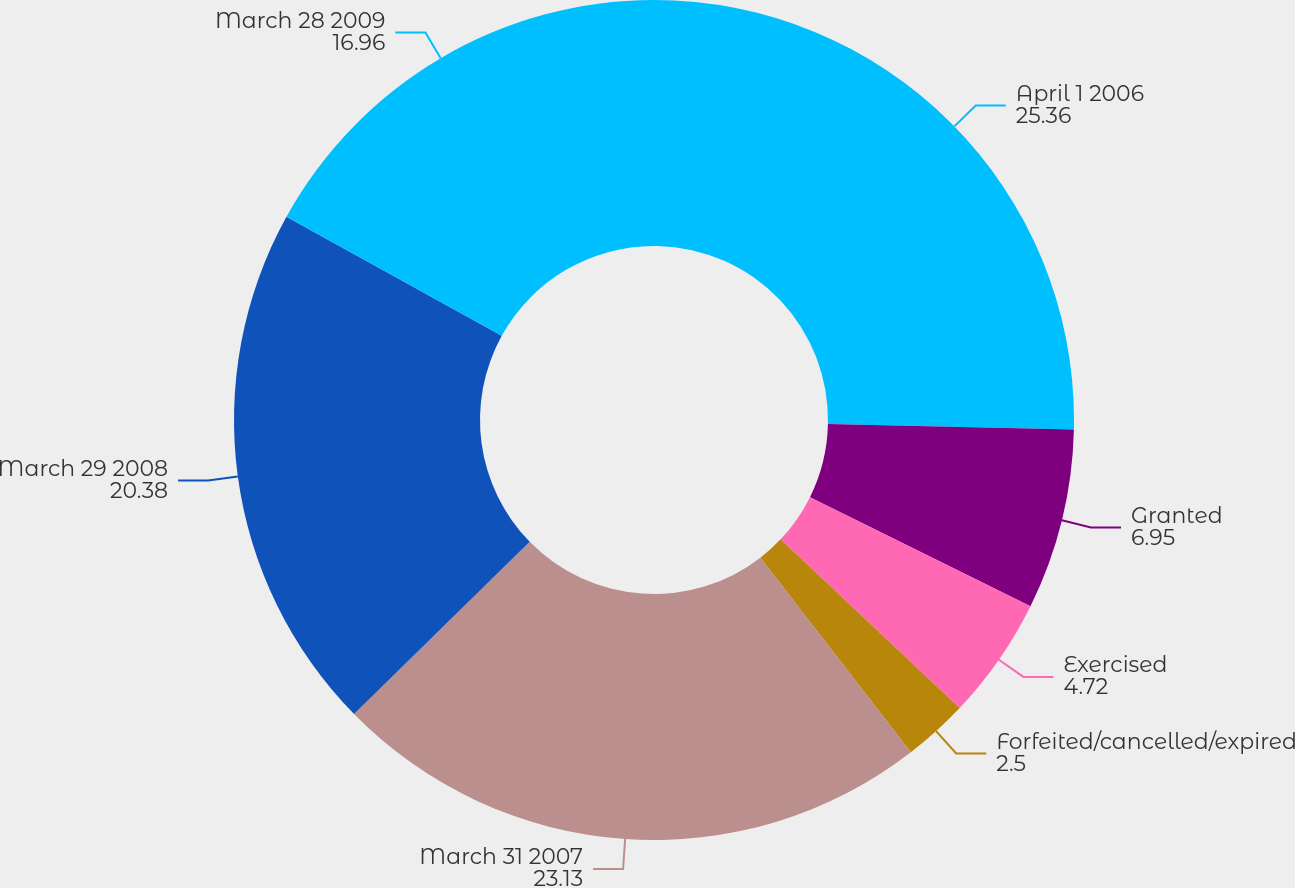Convert chart to OTSL. <chart><loc_0><loc_0><loc_500><loc_500><pie_chart><fcel>April 1 2006<fcel>Granted<fcel>Exercised<fcel>Forfeited/cancelled/expired<fcel>March 31 2007<fcel>March 29 2008<fcel>March 28 2009<nl><fcel>25.36%<fcel>6.95%<fcel>4.72%<fcel>2.5%<fcel>23.13%<fcel>20.38%<fcel>16.96%<nl></chart> 